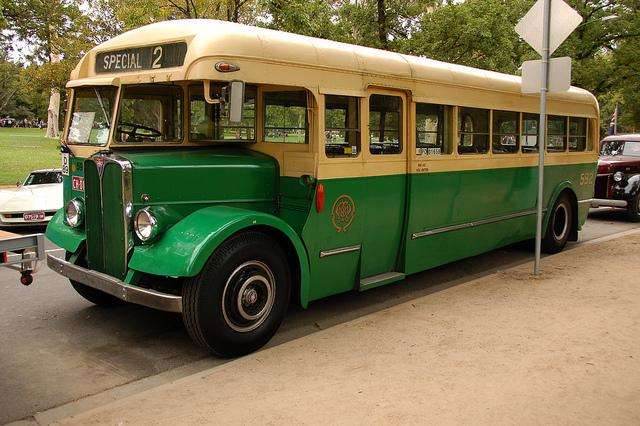Where will the passengers enter? Please explain your reasoning. side. The passengers go on the side. 